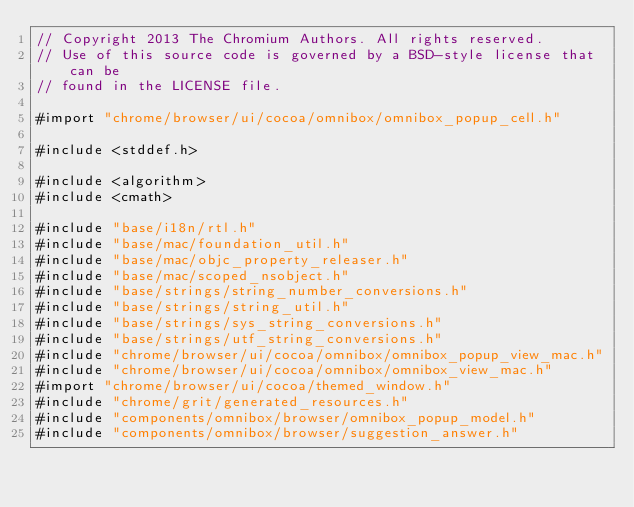Convert code to text. <code><loc_0><loc_0><loc_500><loc_500><_ObjectiveC_>// Copyright 2013 The Chromium Authors. All rights reserved.
// Use of this source code is governed by a BSD-style license that can be
// found in the LICENSE file.

#import "chrome/browser/ui/cocoa/omnibox/omnibox_popup_cell.h"

#include <stddef.h>

#include <algorithm>
#include <cmath>

#include "base/i18n/rtl.h"
#include "base/mac/foundation_util.h"
#include "base/mac/objc_property_releaser.h"
#include "base/mac/scoped_nsobject.h"
#include "base/strings/string_number_conversions.h"
#include "base/strings/string_util.h"
#include "base/strings/sys_string_conversions.h"
#include "base/strings/utf_string_conversions.h"
#include "chrome/browser/ui/cocoa/omnibox/omnibox_popup_view_mac.h"
#include "chrome/browser/ui/cocoa/omnibox/omnibox_view_mac.h"
#import "chrome/browser/ui/cocoa/themed_window.h"
#include "chrome/grit/generated_resources.h"
#include "components/omnibox/browser/omnibox_popup_model.h"
#include "components/omnibox/browser/suggestion_answer.h"</code> 